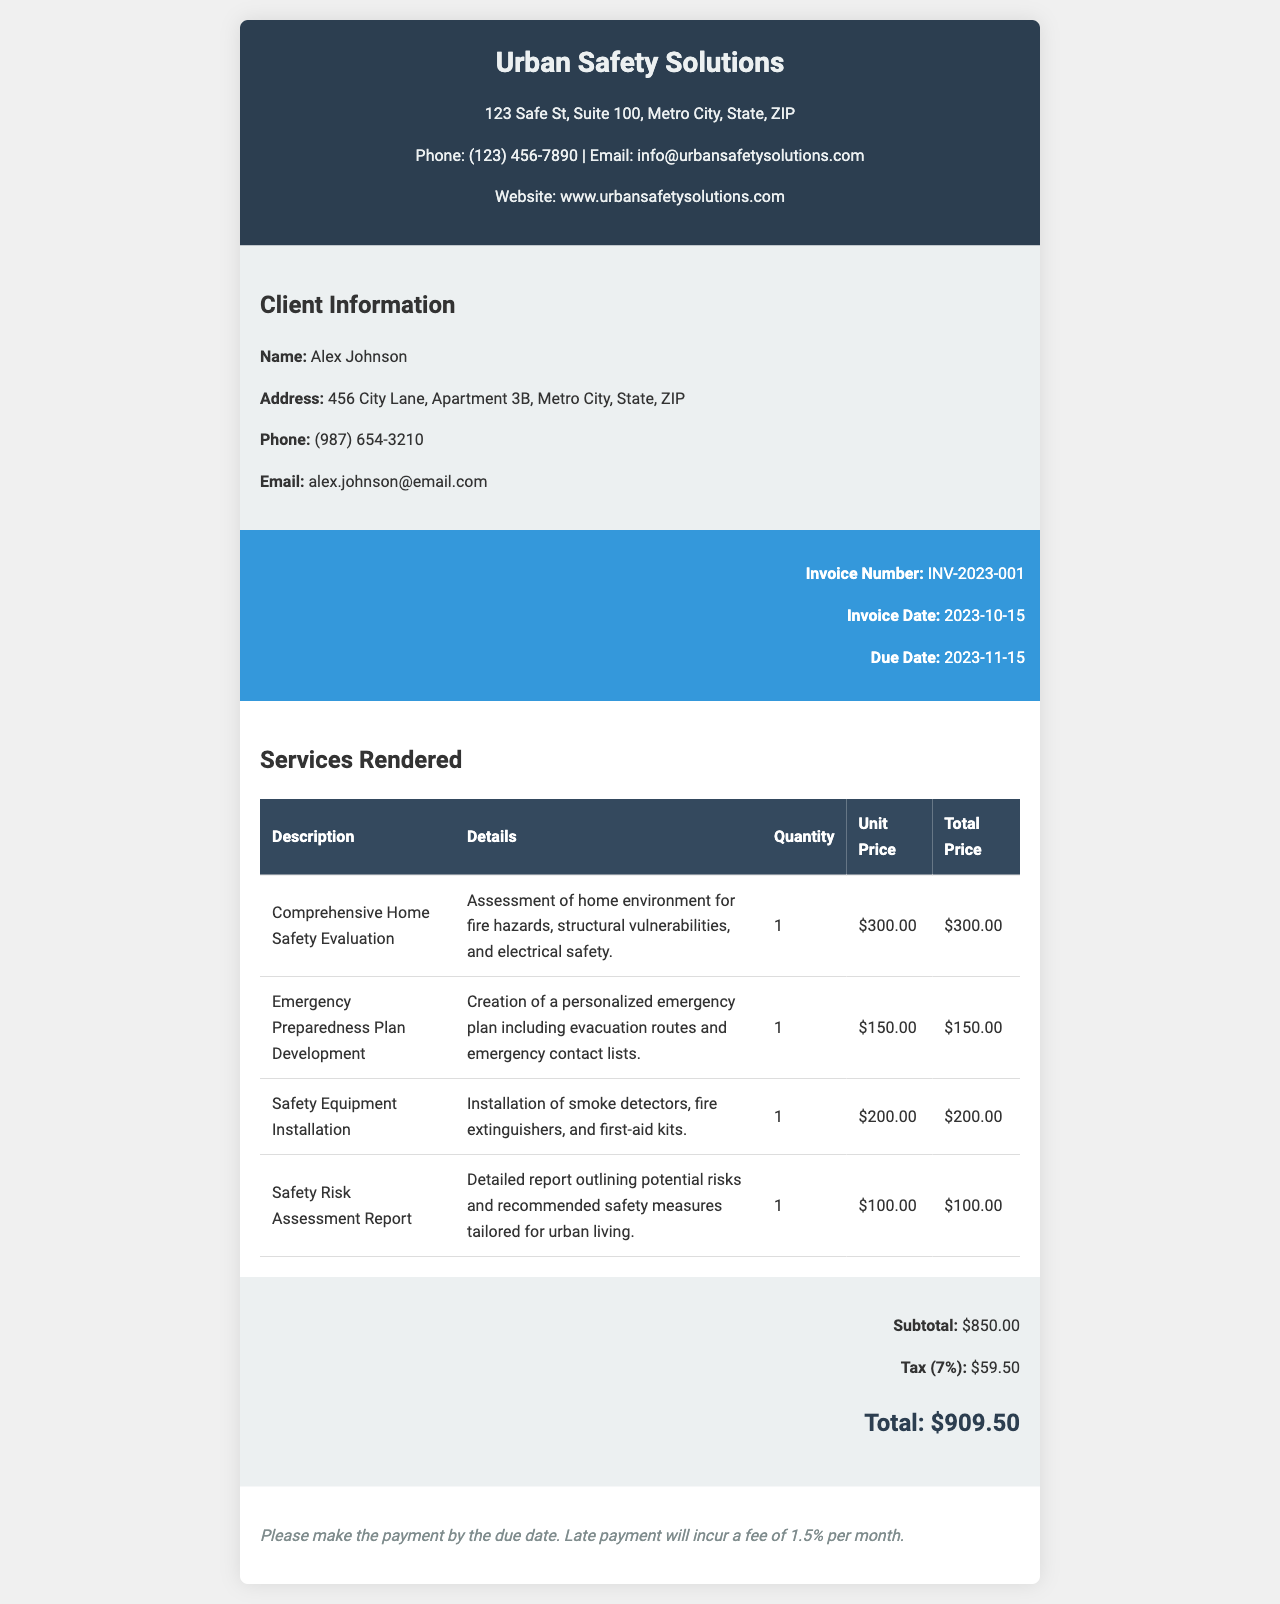What is the name of the client? The client's name is provided in the client details section of the invoice.
Answer: Alex Johnson What services were rendered? The invoice lists several services, each described in detail.
Answer: Comprehensive Home Safety Evaluation, Emergency Preparedness Plan Development, Safety Equipment Installation, Safety Risk Assessment Report What is the total amount due? The total amount due is shown prominently in the summary section of the invoice.
Answer: $909.50 What is the due date for payment? The due date can be found in the invoice details section.
Answer: 2023-11-15 What is the tax rate applied? The tax rate is explicitly stated in the summary section of the invoice.
Answer: 7% How much is the subtotal before tax? The subtotal is listed in the summary section, calculated from the services rendered.
Answer: $850.00 What are the late payment fees? The late payment terms are specified at the bottom of the invoice, indicating the consequence of late payment.
Answer: 1.5% per month What is the invoice number? The invoice number is provided in the invoice details, aiding in identification.
Answer: INV-2023-001 